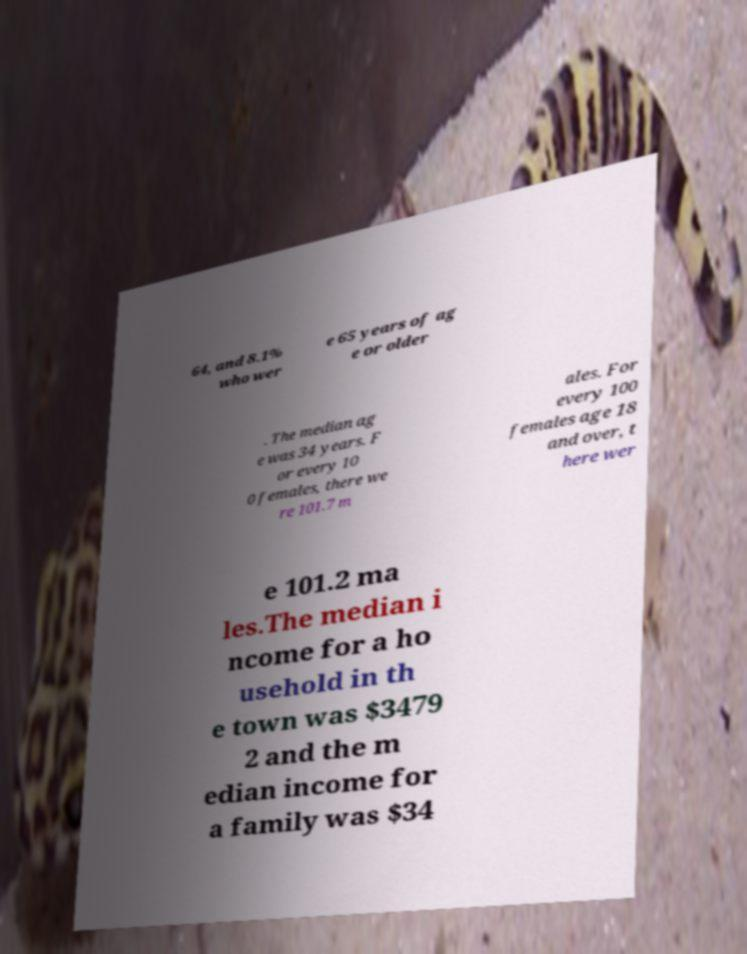I need the written content from this picture converted into text. Can you do that? 64, and 8.1% who wer e 65 years of ag e or older . The median ag e was 34 years. F or every 10 0 females, there we re 101.7 m ales. For every 100 females age 18 and over, t here wer e 101.2 ma les.The median i ncome for a ho usehold in th e town was $3479 2 and the m edian income for a family was $34 